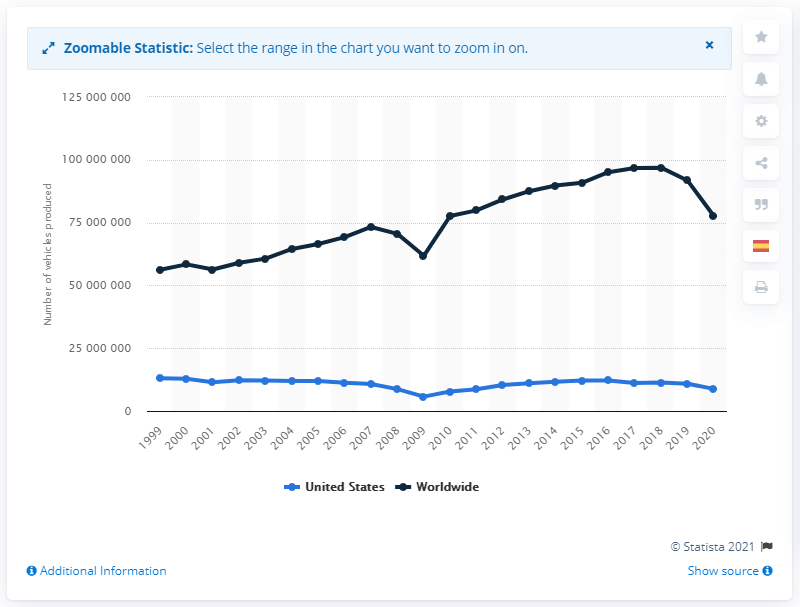Highlight a few significant elements in this photo. In 2020, a total of 882,2399 motor vehicles were produced in the United States. In the same year, a total of 77,621,582 motor vehicles were produced worldwide. 